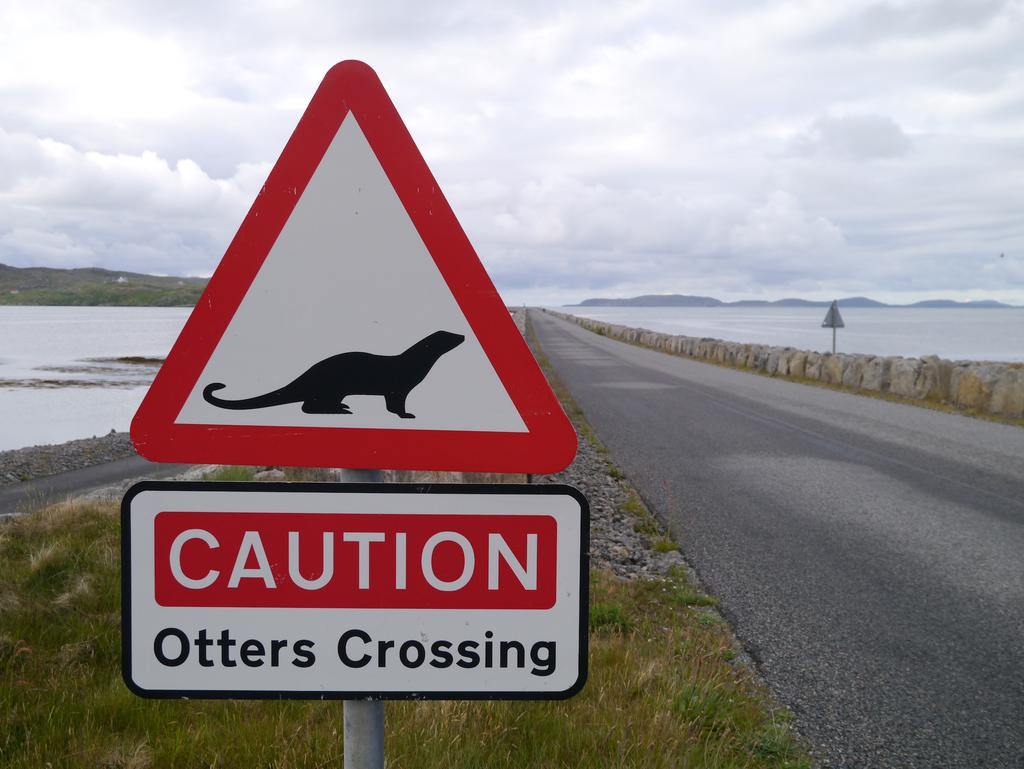<image>
Create a compact narrative representing the image presented. A white sign with a black profile of an otter with red boarders near a road warning of otters crossing. 